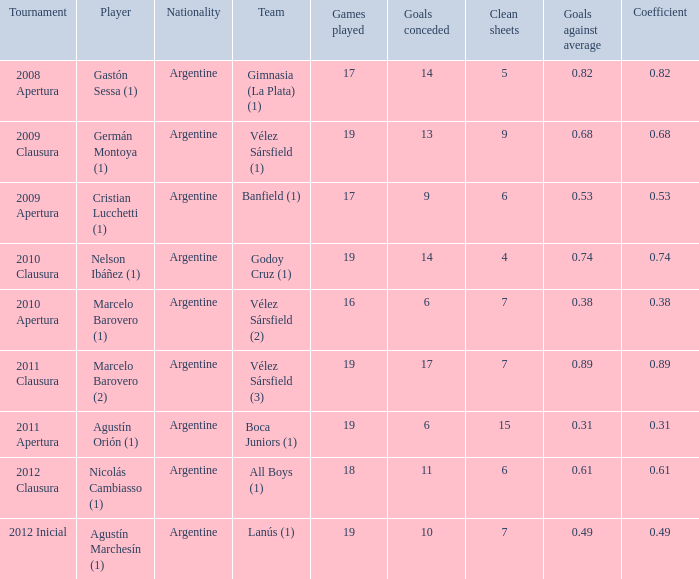What is the nationality of the 2012 clausura  tournament? Argentine. 